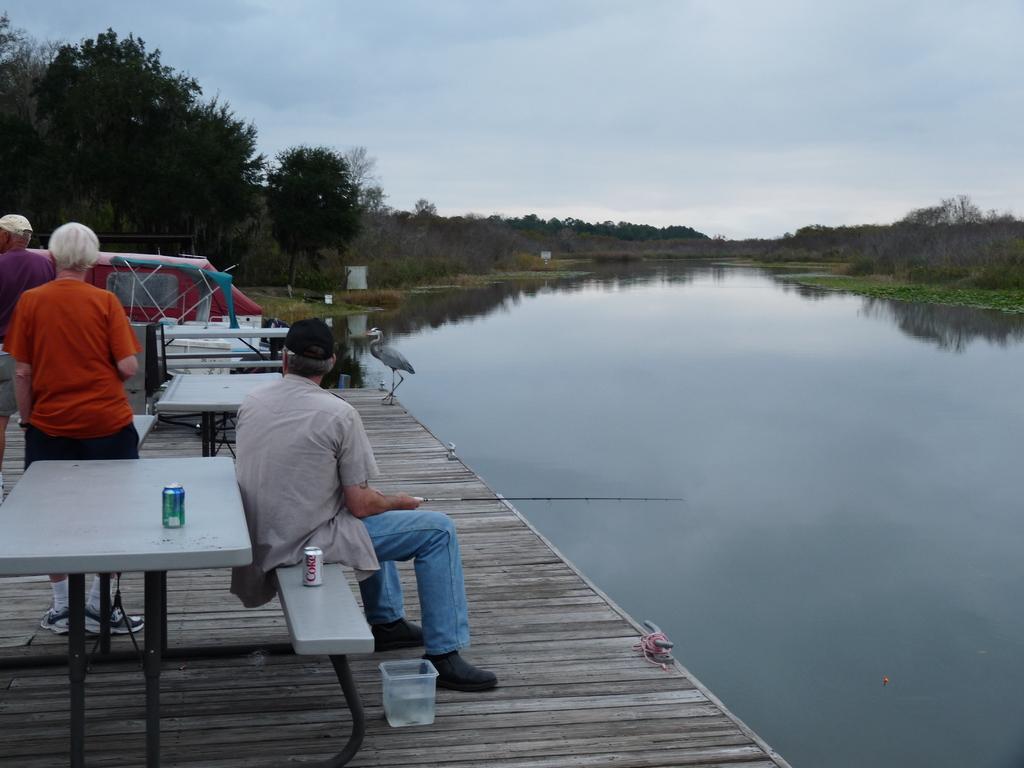Please provide a concise description of this image. On the left side of the image we can see bridge, tables, tins, container, some persons, bird, boat. In the background of the image we can see trees, water. At the top of the image we can see the sky. 